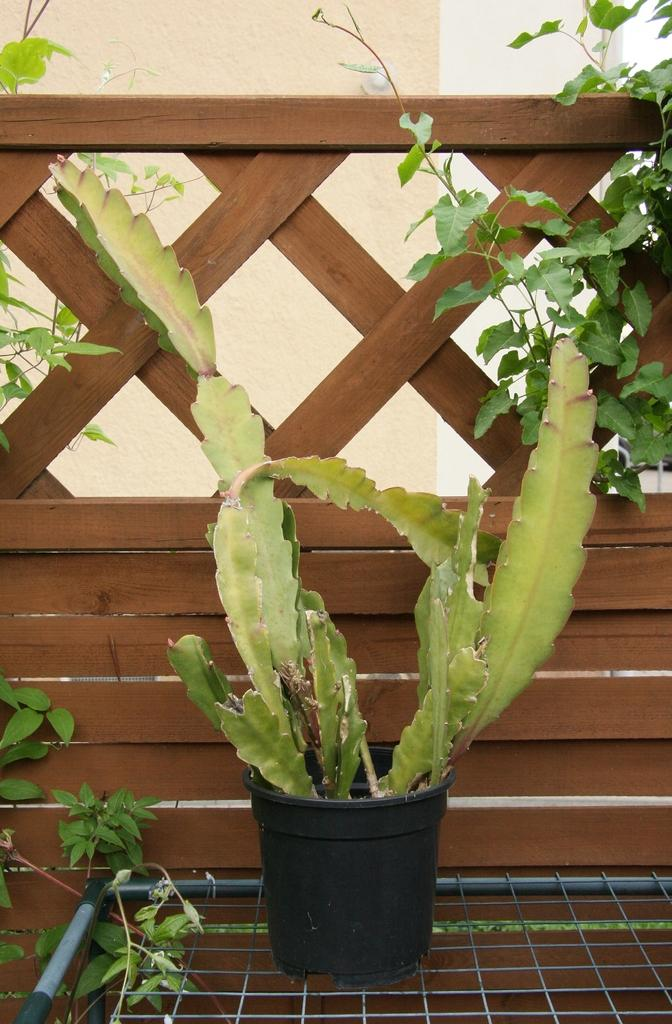What object is present in the image that typically holds plants? There is a plant pot in the image. Where is the plant pot located in relation to the metal grill? The plant pot is on a metal grill. At what position is the metal grill in the image? The metal grill is at the bottom of the image. What type of barrier can be seen in the image? There is a wooden fence in the image. What color is associated with the leaves visible in the image? The leaves visible in the image are green. What is visible in the background of the image? There is a wall in the background of the image. How many clocks are hanging on the wooden fence in the image? There are no clocks visible on the wooden fence in the image. What type of business is being conducted in the image? The image does not depict any business activity; it primarily features a plant pot, metal grill, and wooden fence. 